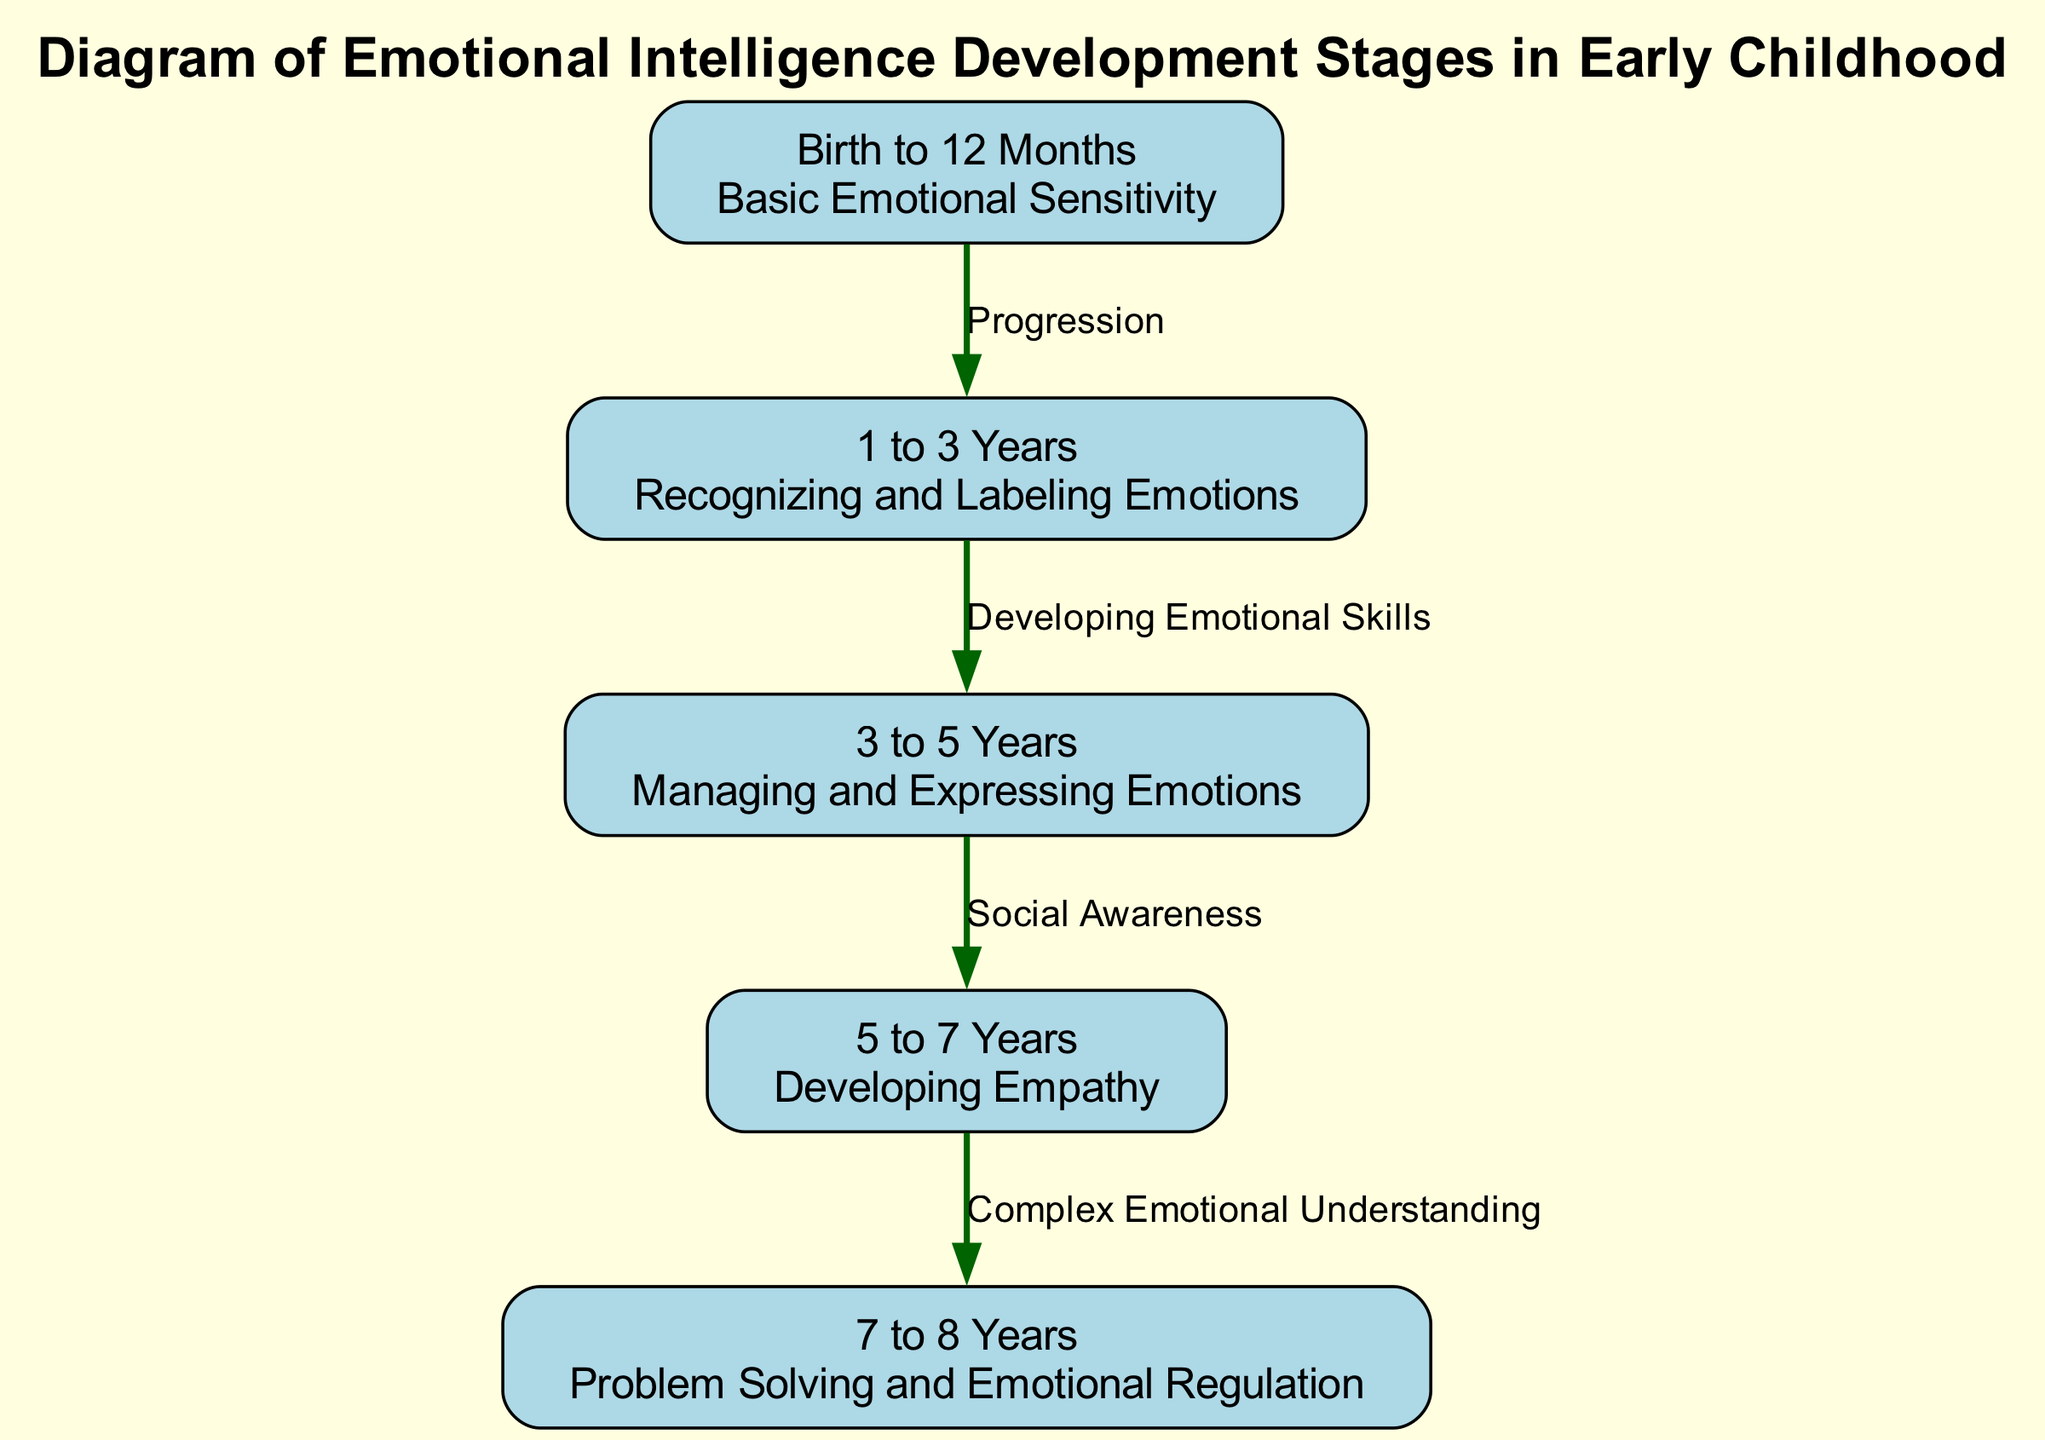What is the label for the first stage of emotional intelligence development? The first stage of emotional intelligence development is labeled "Birth to 12 Months." This can be found by looking at the first node in the diagram.
Answer: Birth to 12 Months How many stages are there in the diagram? By counting the nodes provided in the diagram, we find there are five distinct stages of emotional intelligence development listed.
Answer: 5 What is the content associated with the stage labeled "3 to 5 Years"? The content for the stage labeled "3 to 5 Years" describes "Managing and Expressing Emotions." This information can be seen clearly in the node corresponding to that stage.
Answer: Managing and Expressing Emotions What is the relationship between the "5 to 7 Years" stage and the "7 to 8 Years" stage? The relationship is labeled as "Complex Emotional Understanding," indicating a developmental connection where the later stage builds upon the earlier one. This can be inferred from the edge connecting these two stages.
Answer: Complex Emotional Understanding Which stage comes after "Recognizing and Labeling Emotions"? "Managing and Expressing Emotions" is the next stage, and this progression can be identified by examining the flow indicated by the edges in the diagram.
Answer: Managing and Expressing Emotions What skills are developed during the "5 to 7 Years" stage? During this stage, the skills focused on are described as "Developing Empathy." This content is directly visible in the node representing this particular age range.
Answer: Developing Empathy What connects "3 to 5 Years" to "5 to 7 Years" in the diagram? The two stages are connected by the label "Social Awareness," which denotes the type of relationship or progression between these stages in emotional intelligence development.
Answer: Social Awareness What type of emotional skills are recognized between "1 to 3 Years" and "3 to 5 Years"? The progression indicates "Developing Emotional Skills." This relationship is documented on the edge connecting these two stages in the diagram.
Answer: Developing Emotional Skills 